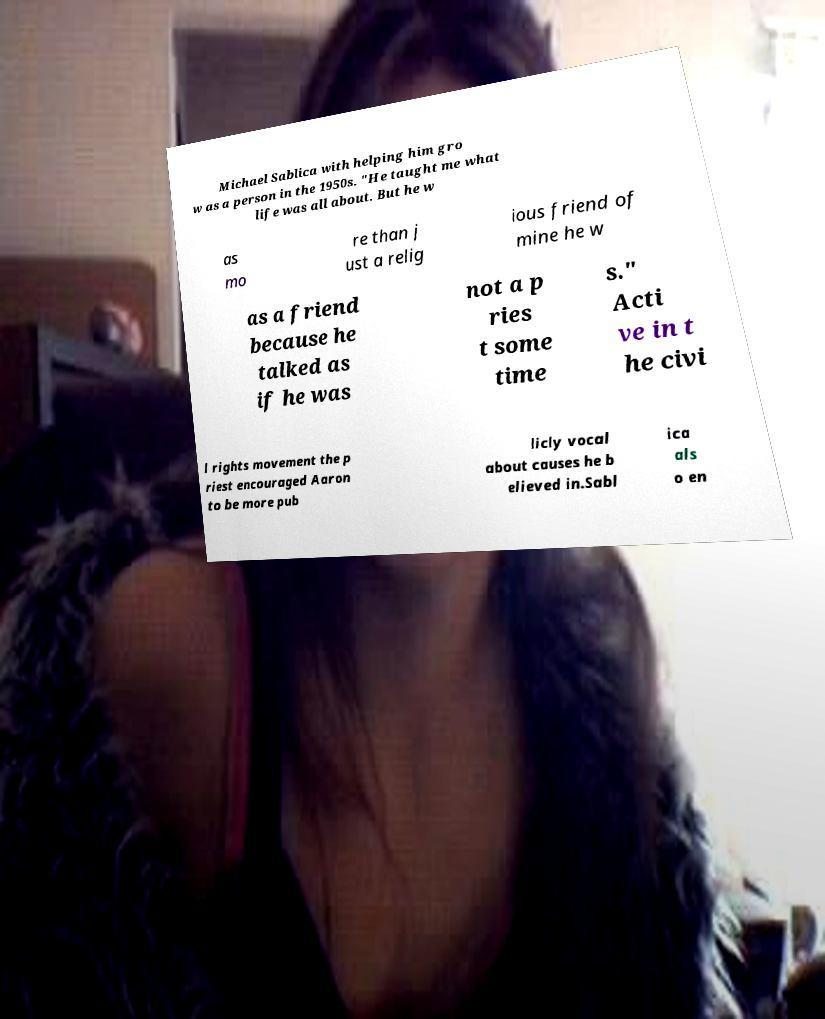Could you assist in decoding the text presented in this image and type it out clearly? Michael Sablica with helping him gro w as a person in the 1950s. "He taught me what life was all about. But he w as mo re than j ust a relig ious friend of mine he w as a friend because he talked as if he was not a p ries t some time s." Acti ve in t he civi l rights movement the p riest encouraged Aaron to be more pub licly vocal about causes he b elieved in.Sabl ica als o en 